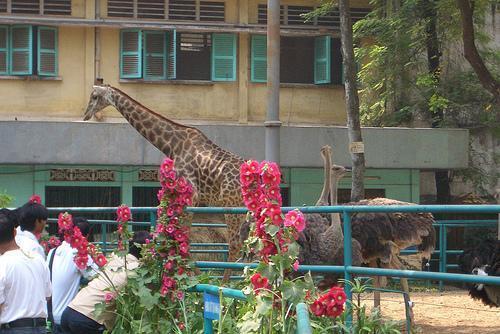How many people are watching the animals?
Give a very brief answer. 4. How many ostriches can you see?
Give a very brief answer. 2. How many giraffes are eating people?
Give a very brief answer. 0. 